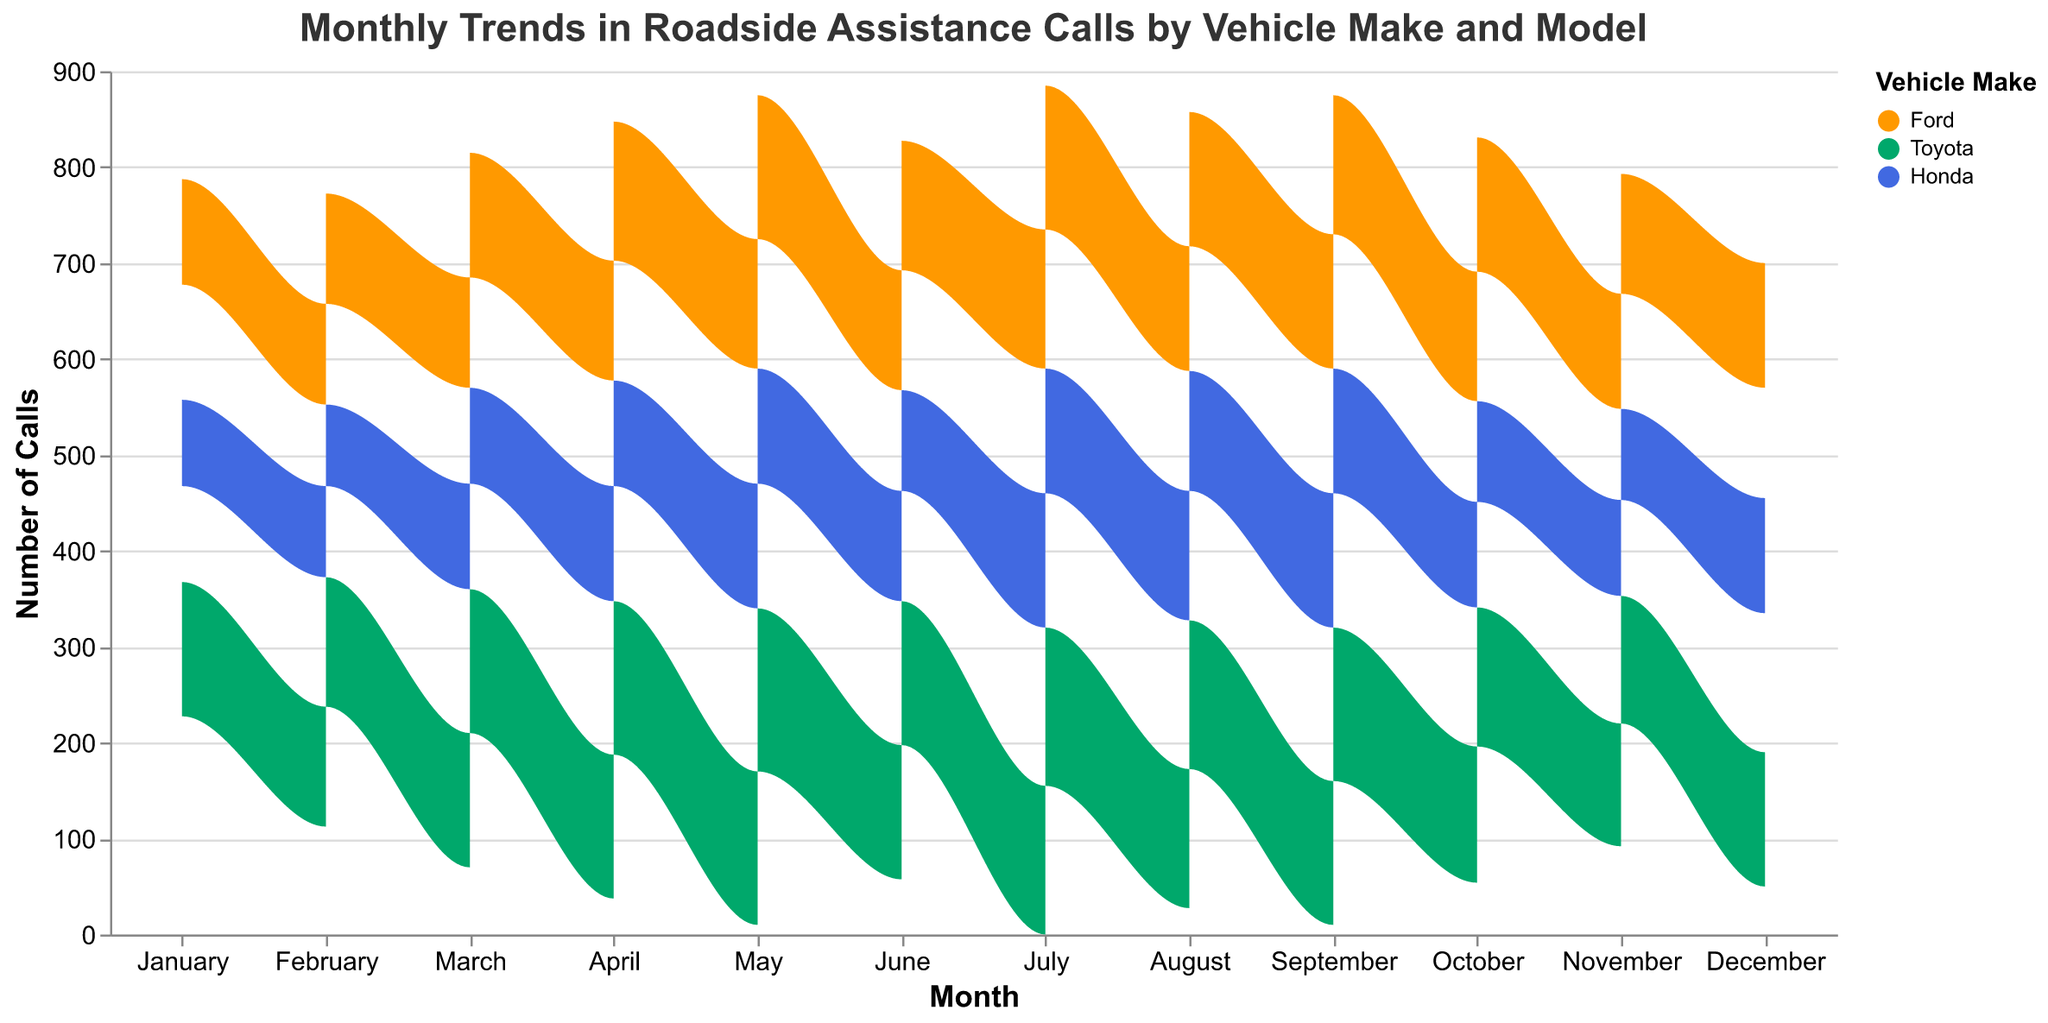What does the title of the graph indicate? The title provides an overview of what the graph is about. It specifies that the graph displays monthly trends in roadside assistance calls, broken down by vehicle make and model
Answer: Monthly Trends in Roadside Assistance Calls by Vehicle Make and Model In which month did Ford Fiesta have the highest number of calls? By observing the height of the area corresponding to Ford Fiesta across the months, you will notice that July has the peak height for Ford Fiesta
Answer: July How do the number of roadside assistance calls for Toyota Camry in May compare to June? Comparing the heights of the areas corresponding to Toyota Camry in May and June, you can see that the area in May is higher than in June. This indicates that the number of calls in May is greater than in June
Answer: May has more calls than June What is the overall trend for Honda Civic from January to December? By following the area plot for Honda Civic from January to December, it initially starts low in January, peaks in July, and then declines towards December
Answer: An overall upward trend peaking in July and then a decline Which vehicle make has the most significant increase in the number of calls from February to March? Comparing the change in area heights from February to March for all vehicle makes, Ford shows a noticeable increase for both Fiesta and Focus models
Answer: Ford What is the total number of calls for Ford vehicles in August? Sum the number of calls for Ford Fiesta and Ford Focus in August. Fiesta has 130 calls, and Focus has 140
Answer: 270 In which month does Toyota make the highest combined number of calls? By observing the total height of areas where Toyota Corolla and Toyota Camry are combined, May exhibits the highest combined calls for the Toyota make
Answer: May Compare the number of roadside assistance calls between Honda Accord and Toyota Corolla in December In December, compare the heights of the areas for Honda Accord and Toyota Corolla. Toyota Corolla has a higher area than Honda Accord
Answer: Toyota Corolla has more calls During which month does the number of calls for Honda Accord surpass that of Honda Civic? Look at the months on the x-axis and compare the height of the areas for Honda Accord and Honda Civic. July shows Honda Accord has more calls than Honda Civic
Answer: July What does the color blue represent in the graph? Referring to the legend, the color blue is assigned to Honda
Answer: Honda 